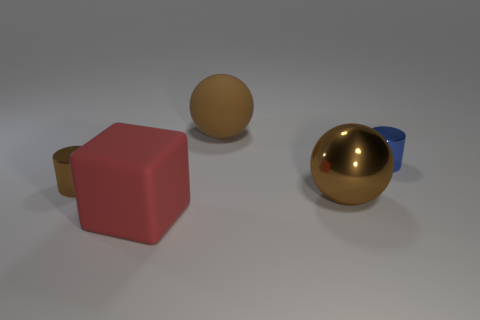Add 3 big green shiny balls. How many objects exist? 8 Subtract all cylinders. How many objects are left? 3 Add 4 brown matte objects. How many brown matte objects are left? 5 Add 1 brown metal cylinders. How many brown metal cylinders exist? 2 Subtract 0 blue cubes. How many objects are left? 5 Subtract all green metallic cylinders. Subtract all small blue cylinders. How many objects are left? 4 